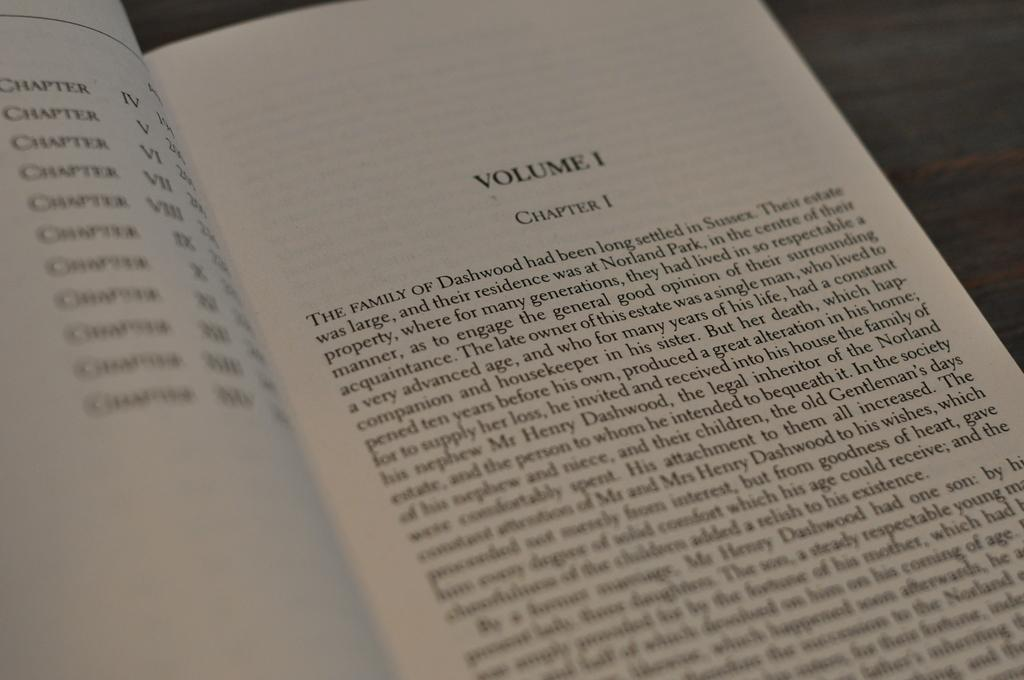<image>
Summarize the visual content of the image. Volume one Chapter one written in Black and white laying on a table. 